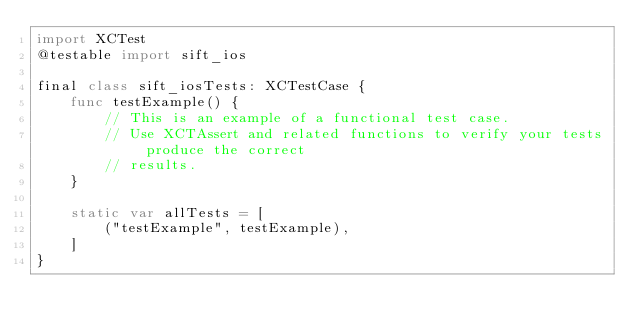Convert code to text. <code><loc_0><loc_0><loc_500><loc_500><_Swift_>import XCTest
@testable import sift_ios

final class sift_iosTests: XCTestCase {
    func testExample() {
        // This is an example of a functional test case.
        // Use XCTAssert and related functions to verify your tests produce the correct
        // results.
    }

    static var allTests = [
        ("testExample", testExample),
    ]
}
</code> 